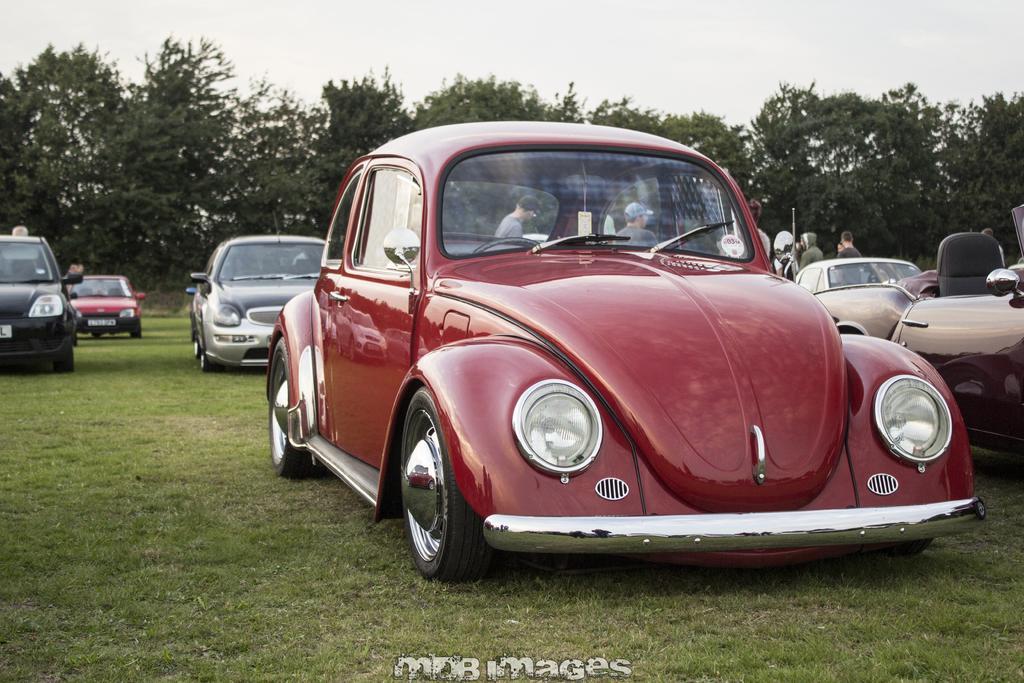Can you describe this image briefly? In this image, we can see some cars. There are trees in the middle of the image. There is a sky at the top of the image. 